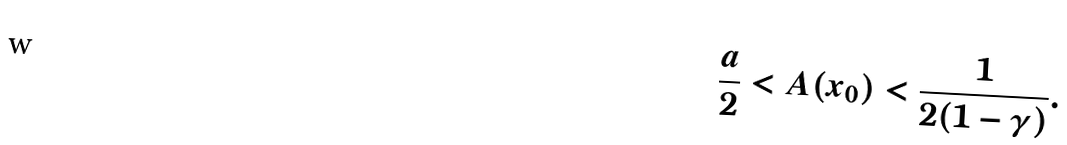Convert formula to latex. <formula><loc_0><loc_0><loc_500><loc_500>\frac { a } { 2 } < A ( x _ { 0 } ) < \frac { 1 } { 2 ( 1 - \gamma ) } .</formula> 